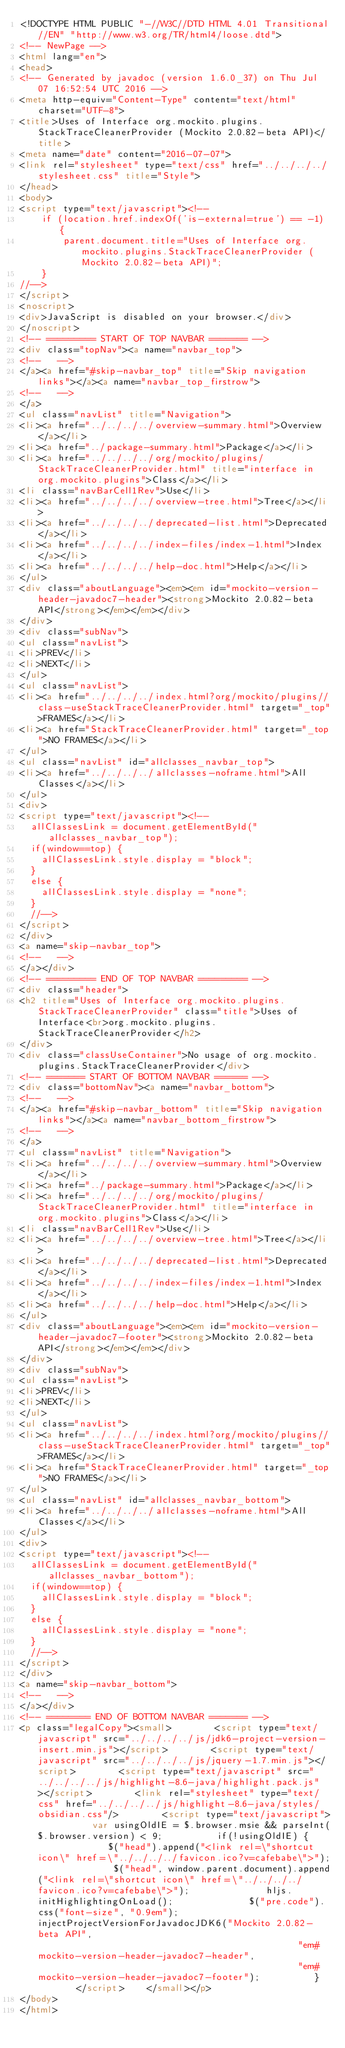Convert code to text. <code><loc_0><loc_0><loc_500><loc_500><_HTML_><!DOCTYPE HTML PUBLIC "-//W3C//DTD HTML 4.01 Transitional//EN" "http://www.w3.org/TR/html4/loose.dtd">
<!-- NewPage -->
<html lang="en">
<head>
<!-- Generated by javadoc (version 1.6.0_37) on Thu Jul 07 16:52:54 UTC 2016 -->
<meta http-equiv="Content-Type" content="text/html" charset="UTF-8">
<title>Uses of Interface org.mockito.plugins.StackTraceCleanerProvider (Mockito 2.0.82-beta API)</title>
<meta name="date" content="2016-07-07">
<link rel="stylesheet" type="text/css" href="../../../../stylesheet.css" title="Style">
</head>
<body>
<script type="text/javascript"><!--
    if (location.href.indexOf('is-external=true') == -1) {
        parent.document.title="Uses of Interface org.mockito.plugins.StackTraceCleanerProvider (Mockito 2.0.82-beta API)";
    }
//-->
</script>
<noscript>
<div>JavaScript is disabled on your browser.</div>
</noscript>
<!-- ========= START OF TOP NAVBAR ======= -->
<div class="topNav"><a name="navbar_top">
<!--   -->
</a><a href="#skip-navbar_top" title="Skip navigation links"></a><a name="navbar_top_firstrow">
<!--   -->
</a>
<ul class="navList" title="Navigation">
<li><a href="../../../../overview-summary.html">Overview</a></li>
<li><a href="../package-summary.html">Package</a></li>
<li><a href="../../../../org/mockito/plugins/StackTraceCleanerProvider.html" title="interface in org.mockito.plugins">Class</a></li>
<li class="navBarCell1Rev">Use</li>
<li><a href="../../../../overview-tree.html">Tree</a></li>
<li><a href="../../../../deprecated-list.html">Deprecated</a></li>
<li><a href="../../../../index-files/index-1.html">Index</a></li>
<li><a href="../../../../help-doc.html">Help</a></li>
</ul>
<div class="aboutLanguage"><em><em id="mockito-version-header-javadoc7-header"><strong>Mockito 2.0.82-beta API</strong></em></em></div>
</div>
<div class="subNav">
<ul class="navList">
<li>PREV</li>
<li>NEXT</li>
</ul>
<ul class="navList">
<li><a href="../../../../index.html?org/mockito/plugins//class-useStackTraceCleanerProvider.html" target="_top">FRAMES</a></li>
<li><a href="StackTraceCleanerProvider.html" target="_top">NO FRAMES</a></li>
</ul>
<ul class="navList" id="allclasses_navbar_top">
<li><a href="../../../../allclasses-noframe.html">All Classes</a></li>
</ul>
<div>
<script type="text/javascript"><!--
  allClassesLink = document.getElementById("allclasses_navbar_top");
  if(window==top) {
    allClassesLink.style.display = "block";
  }
  else {
    allClassesLink.style.display = "none";
  }
  //-->
</script>
</div>
<a name="skip-navbar_top">
<!--   -->
</a></div>
<!-- ========= END OF TOP NAVBAR ========= -->
<div class="header">
<h2 title="Uses of Interface org.mockito.plugins.StackTraceCleanerProvider" class="title">Uses of Interface<br>org.mockito.plugins.StackTraceCleanerProvider</h2>
</div>
<div class="classUseContainer">No usage of org.mockito.plugins.StackTraceCleanerProvider</div>
<!-- ======= START OF BOTTOM NAVBAR ====== -->
<div class="bottomNav"><a name="navbar_bottom">
<!--   -->
</a><a href="#skip-navbar_bottom" title="Skip navigation links"></a><a name="navbar_bottom_firstrow">
<!--   -->
</a>
<ul class="navList" title="Navigation">
<li><a href="../../../../overview-summary.html">Overview</a></li>
<li><a href="../package-summary.html">Package</a></li>
<li><a href="../../../../org/mockito/plugins/StackTraceCleanerProvider.html" title="interface in org.mockito.plugins">Class</a></li>
<li class="navBarCell1Rev">Use</li>
<li><a href="../../../../overview-tree.html">Tree</a></li>
<li><a href="../../../../deprecated-list.html">Deprecated</a></li>
<li><a href="../../../../index-files/index-1.html">Index</a></li>
<li><a href="../../../../help-doc.html">Help</a></li>
</ul>
<div class="aboutLanguage"><em><em id="mockito-version-header-javadoc7-footer"><strong>Mockito 2.0.82-beta API</strong></em></em></div>
</div>
<div class="subNav">
<ul class="navList">
<li>PREV</li>
<li>NEXT</li>
</ul>
<ul class="navList">
<li><a href="../../../../index.html?org/mockito/plugins//class-useStackTraceCleanerProvider.html" target="_top">FRAMES</a></li>
<li><a href="StackTraceCleanerProvider.html" target="_top">NO FRAMES</a></li>
</ul>
<ul class="navList" id="allclasses_navbar_bottom">
<li><a href="../../../../allclasses-noframe.html">All Classes</a></li>
</ul>
<div>
<script type="text/javascript"><!--
  allClassesLink = document.getElementById("allclasses_navbar_bottom");
  if(window==top) {
    allClassesLink.style.display = "block";
  }
  else {
    allClassesLink.style.display = "none";
  }
  //-->
</script>
</div>
<a name="skip-navbar_bottom">
<!--   -->
</a></div>
<!-- ======== END OF BOTTOM NAVBAR ======= -->
<p class="legalCopy"><small>        <script type="text/javascript" src="../../../../js/jdk6-project-version-insert.min.js"></script>        <script type="text/javascript" src="../../../../js/jquery-1.7.min.js"></script>        <script type="text/javascript" src="../../../../js/highlight-8.6-java/highlight.pack.js"></script>        <link rel="stylesheet" type="text/css" href="../../../../js/highlight-8.6-java/styles/obsidian.css"/>        <script type="text/javascript">          var usingOldIE = $.browser.msie && parseInt($.browser.version) < 9;          if(!usingOldIE) {              $("head").append("<link rel=\"shortcut icon\" href=\"../../../../favicon.ico?v=cafebabe\">");              $("head", window.parent.document).append("<link rel=\"shortcut icon\" href=\"../../../../favicon.ico?v=cafebabe\">");              hljs.initHighlightingOnLoad();              $("pre.code").css("font-size", "0.9em");              injectProjectVersionForJavadocJDK6("Mockito 2.0.82-beta API",                                                 "em#mockito-version-header-javadoc7-header",                                                 "em#mockito-version-header-javadoc7-footer");          }        </script>    </small></p>
</body>
</html>
</code> 